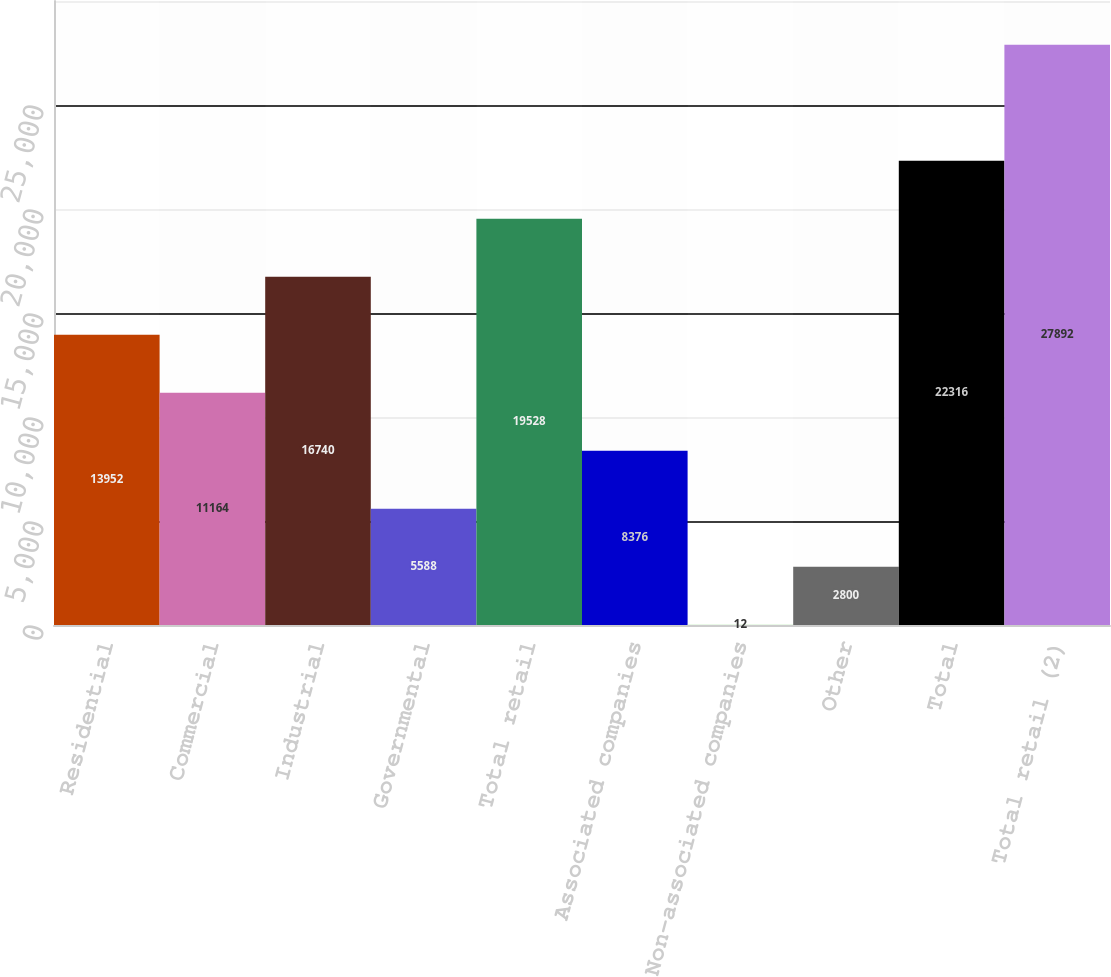Convert chart. <chart><loc_0><loc_0><loc_500><loc_500><bar_chart><fcel>Residential<fcel>Commercial<fcel>Industrial<fcel>Governmental<fcel>Total retail<fcel>Associated companies<fcel>Non-associated companies<fcel>Other<fcel>Total<fcel>Total retail (2)<nl><fcel>13952<fcel>11164<fcel>16740<fcel>5588<fcel>19528<fcel>8376<fcel>12<fcel>2800<fcel>22316<fcel>27892<nl></chart> 